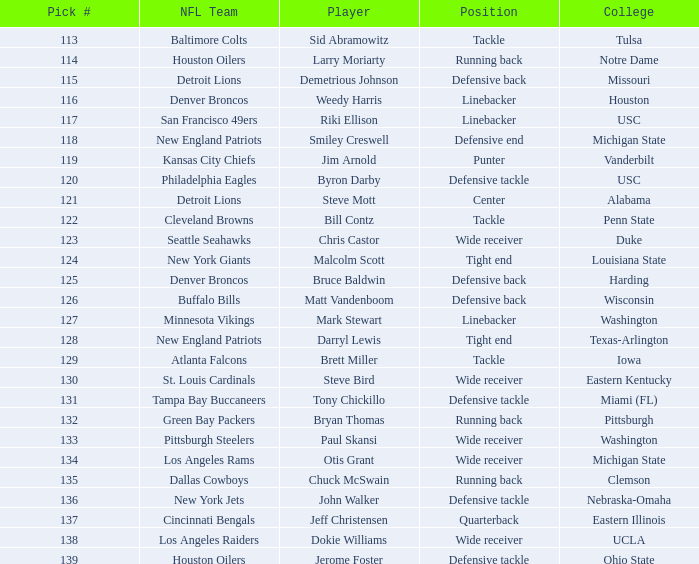Can you give me this table as a dict? {'header': ['Pick #', 'NFL Team', 'Player', 'Position', 'College'], 'rows': [['113', 'Baltimore Colts', 'Sid Abramowitz', 'Tackle', 'Tulsa'], ['114', 'Houston Oilers', 'Larry Moriarty', 'Running back', 'Notre Dame'], ['115', 'Detroit Lions', 'Demetrious Johnson', 'Defensive back', 'Missouri'], ['116', 'Denver Broncos', 'Weedy Harris', 'Linebacker', 'Houston'], ['117', 'San Francisco 49ers', 'Riki Ellison', 'Linebacker', 'USC'], ['118', 'New England Patriots', 'Smiley Creswell', 'Defensive end', 'Michigan State'], ['119', 'Kansas City Chiefs', 'Jim Arnold', 'Punter', 'Vanderbilt'], ['120', 'Philadelphia Eagles', 'Byron Darby', 'Defensive tackle', 'USC'], ['121', 'Detroit Lions', 'Steve Mott', 'Center', 'Alabama'], ['122', 'Cleveland Browns', 'Bill Contz', 'Tackle', 'Penn State'], ['123', 'Seattle Seahawks', 'Chris Castor', 'Wide receiver', 'Duke'], ['124', 'New York Giants', 'Malcolm Scott', 'Tight end', 'Louisiana State'], ['125', 'Denver Broncos', 'Bruce Baldwin', 'Defensive back', 'Harding'], ['126', 'Buffalo Bills', 'Matt Vandenboom', 'Defensive back', 'Wisconsin'], ['127', 'Minnesota Vikings', 'Mark Stewart', 'Linebacker', 'Washington'], ['128', 'New England Patriots', 'Darryl Lewis', 'Tight end', 'Texas-Arlington'], ['129', 'Atlanta Falcons', 'Brett Miller', 'Tackle', 'Iowa'], ['130', 'St. Louis Cardinals', 'Steve Bird', 'Wide receiver', 'Eastern Kentucky'], ['131', 'Tampa Bay Buccaneers', 'Tony Chickillo', 'Defensive tackle', 'Miami (FL)'], ['132', 'Green Bay Packers', 'Bryan Thomas', 'Running back', 'Pittsburgh'], ['133', 'Pittsburgh Steelers', 'Paul Skansi', 'Wide receiver', 'Washington'], ['134', 'Los Angeles Rams', 'Otis Grant', 'Wide receiver', 'Michigan State'], ['135', 'Dallas Cowboys', 'Chuck McSwain', 'Running back', 'Clemson'], ['136', 'New York Jets', 'John Walker', 'Defensive tackle', 'Nebraska-Omaha'], ['137', 'Cincinnati Bengals', 'Jeff Christensen', 'Quarterback', 'Eastern Illinois'], ['138', 'Los Angeles Raiders', 'Dokie Williams', 'Wide receiver', 'UCLA'], ['139', 'Houston Oilers', 'Jerome Foster', 'Defensive tackle', 'Ohio State']]} What is the maximum selection number the los angeles raiders obtained? 138.0. 